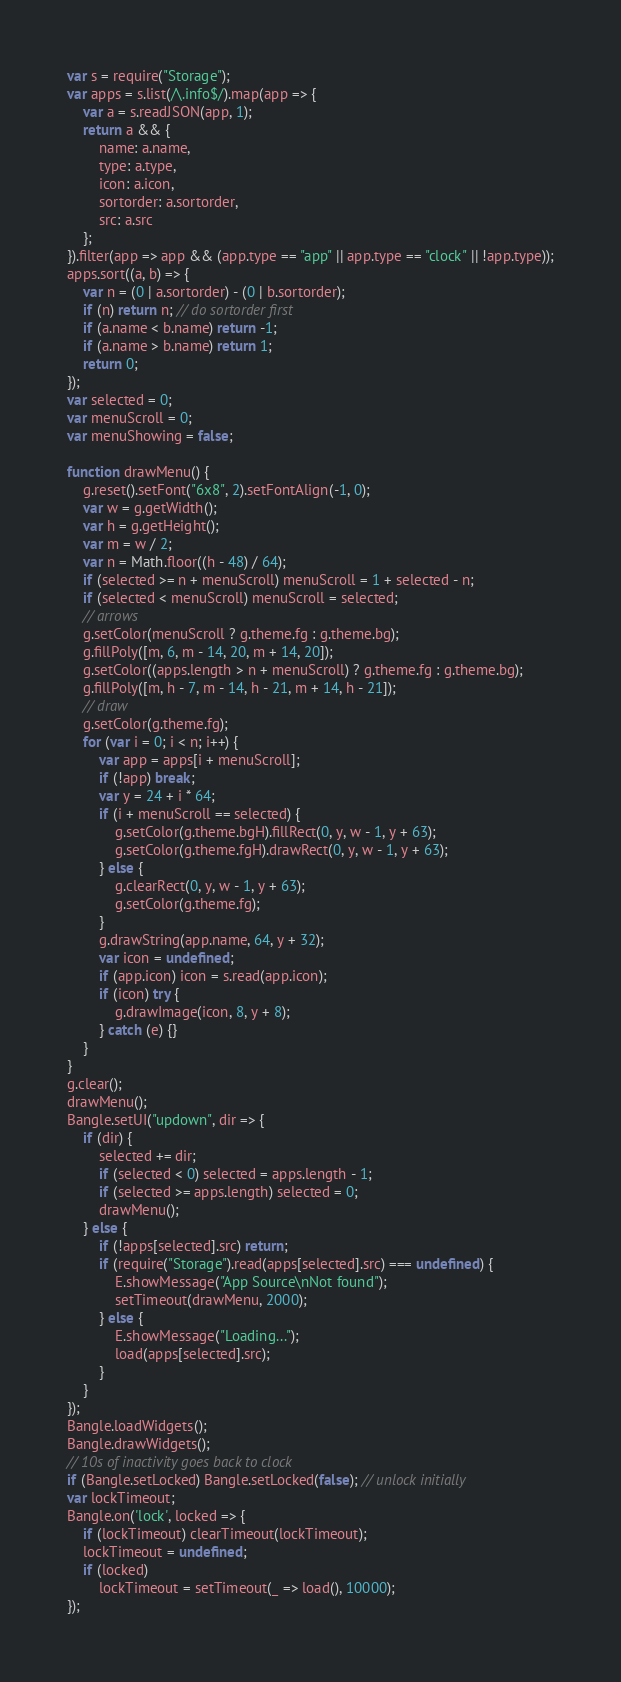Convert code to text. <code><loc_0><loc_0><loc_500><loc_500><_JavaScript_>var s = require("Storage");
var apps = s.list(/\.info$/).map(app => {
    var a = s.readJSON(app, 1);
    return a && {
        name: a.name,
        type: a.type,
        icon: a.icon,
        sortorder: a.sortorder,
        src: a.src
    };
}).filter(app => app && (app.type == "app" || app.type == "clock" || !app.type));
apps.sort((a, b) => {
    var n = (0 | a.sortorder) - (0 | b.sortorder);
    if (n) return n; // do sortorder first
    if (a.name < b.name) return -1;
    if (a.name > b.name) return 1;
    return 0;
});
var selected = 0;
var menuScroll = 0;
var menuShowing = false;

function drawMenu() {
    g.reset().setFont("6x8", 2).setFontAlign(-1, 0);
    var w = g.getWidth();
    var h = g.getHeight();
    var m = w / 2;
    var n = Math.floor((h - 48) / 64);
    if (selected >= n + menuScroll) menuScroll = 1 + selected - n;
    if (selected < menuScroll) menuScroll = selected;
    // arrows
    g.setColor(menuScroll ? g.theme.fg : g.theme.bg);
    g.fillPoly([m, 6, m - 14, 20, m + 14, 20]);
    g.setColor((apps.length > n + menuScroll) ? g.theme.fg : g.theme.bg);
    g.fillPoly([m, h - 7, m - 14, h - 21, m + 14, h - 21]);
    // draw
    g.setColor(g.theme.fg);
    for (var i = 0; i < n; i++) {
        var app = apps[i + menuScroll];
        if (!app) break;
        var y = 24 + i * 64;
        if (i + menuScroll == selected) {
            g.setColor(g.theme.bgH).fillRect(0, y, w - 1, y + 63);
            g.setColor(g.theme.fgH).drawRect(0, y, w - 1, y + 63);
        } else {
            g.clearRect(0, y, w - 1, y + 63);
            g.setColor(g.theme.fg);
        }
        g.drawString(app.name, 64, y + 32);
        var icon = undefined;
        if (app.icon) icon = s.read(app.icon);
        if (icon) try {
            g.drawImage(icon, 8, y + 8);
        } catch (e) {}
    }
}
g.clear();
drawMenu();
Bangle.setUI("updown", dir => {
    if (dir) {
        selected += dir;
        if (selected < 0) selected = apps.length - 1;
        if (selected >= apps.length) selected = 0;
        drawMenu();
    } else {
        if (!apps[selected].src) return;
        if (require("Storage").read(apps[selected].src) === undefined) {
            E.showMessage("App Source\nNot found");
            setTimeout(drawMenu, 2000);
        } else {
            E.showMessage("Loading...");
            load(apps[selected].src);
        }
    }
});
Bangle.loadWidgets();
Bangle.drawWidgets();
// 10s of inactivity goes back to clock
if (Bangle.setLocked) Bangle.setLocked(false); // unlock initially
var lockTimeout;
Bangle.on('lock', locked => {
    if (lockTimeout) clearTimeout(lockTimeout);
    lockTimeout = undefined;
    if (locked)
        lockTimeout = setTimeout(_ => load(), 10000);
});</code> 